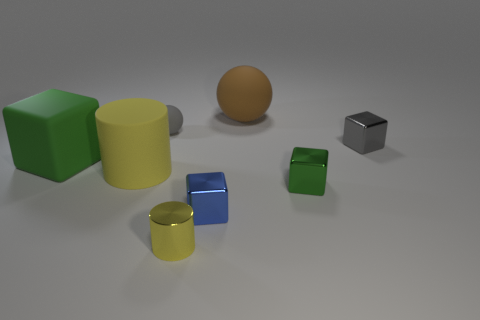Subtract 1 cubes. How many cubes are left? 3 Subtract all red cubes. Subtract all brown spheres. How many cubes are left? 4 Add 1 blue shiny things. How many objects exist? 9 Subtract all spheres. How many objects are left? 6 Subtract all tiny gray metal balls. Subtract all small gray rubber things. How many objects are left? 7 Add 4 matte blocks. How many matte blocks are left? 5 Add 8 yellow things. How many yellow things exist? 10 Subtract 0 purple cylinders. How many objects are left? 8 